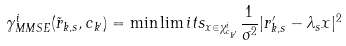Convert formula to latex. <formula><loc_0><loc_0><loc_500><loc_500>\gamma _ { M M S E } ^ { i } ( \tilde { r } _ { k , s } , c _ { k ^ { \prime } } ) = \min \lim i t s _ { x \in \chi _ { c _ { k ^ { \prime } } } ^ { i } } \frac { 1 } { \sigma ^ { 2 } } | r ^ { \prime } _ { k , s } - \lambda _ { s } x | ^ { 2 }</formula> 